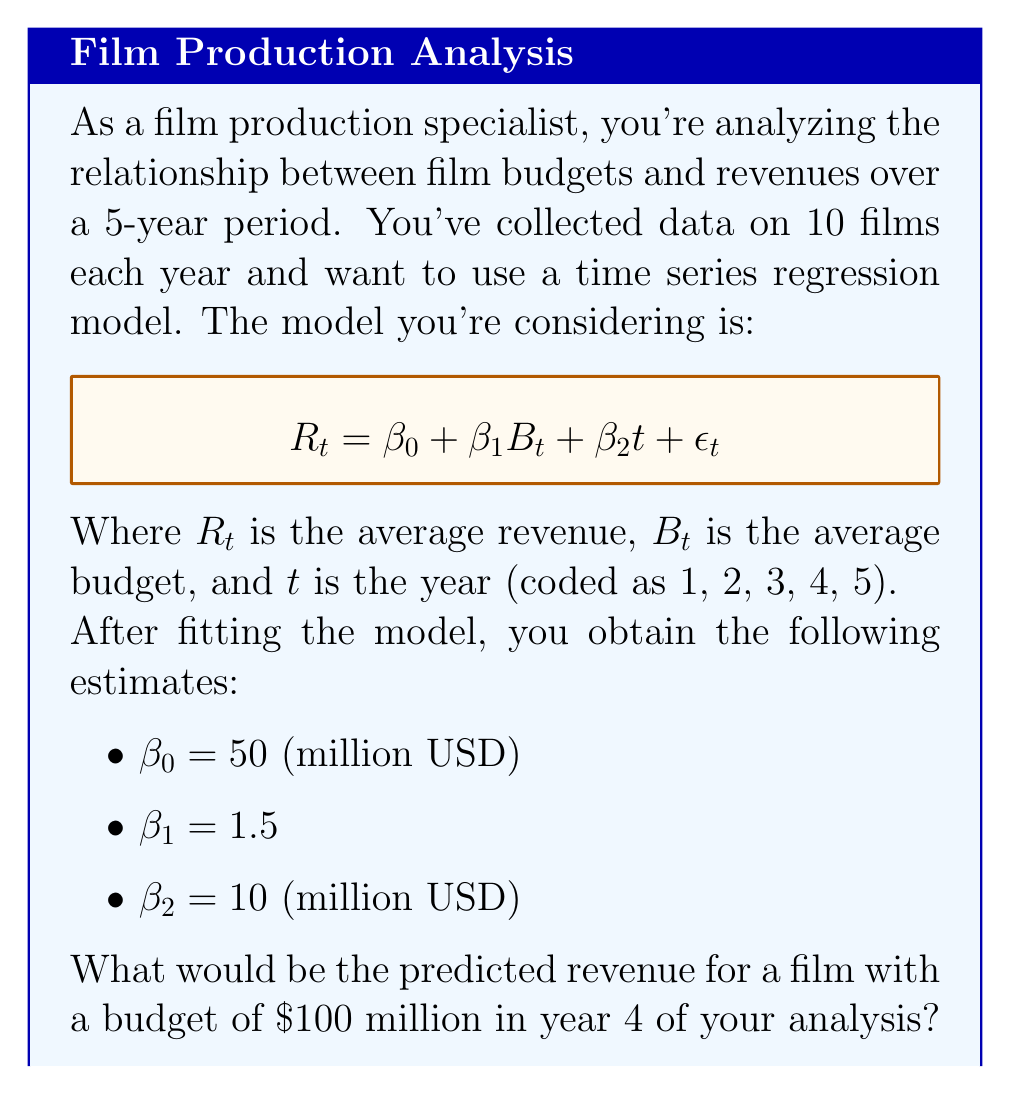Show me your answer to this math problem. Let's approach this step-by-step:

1) We're given the time series regression model:
   $$R_t = \beta_0 + \beta_1B_t + \beta_2t + \epsilon_t$$

2) We have the following estimates:
   $\beta_0 = 50$ million USD
   $\beta_1 = 1.5$
   $\beta_2 = 10$ million USD

3) We're asked about year 4, so $t = 4$

4) The budget is given as $100 million, so $B_t = 100$

5) Let's substitute these values into our model:
   $$R_4 = 50 + 1.5(100) + 10(4) + \epsilon_t$$

6) Simplify:
   $$R_4 = 50 + 150 + 40 + \epsilon_t$$
   $$R_4 = 240 + \epsilon_t$$

7) The $\epsilon_t$ term represents the error or residual. For prediction purposes, we assume this to be zero.

8) Therefore, our predicted revenue is:
   $$R_4 = 240$$ million USD
Answer: $240 million 